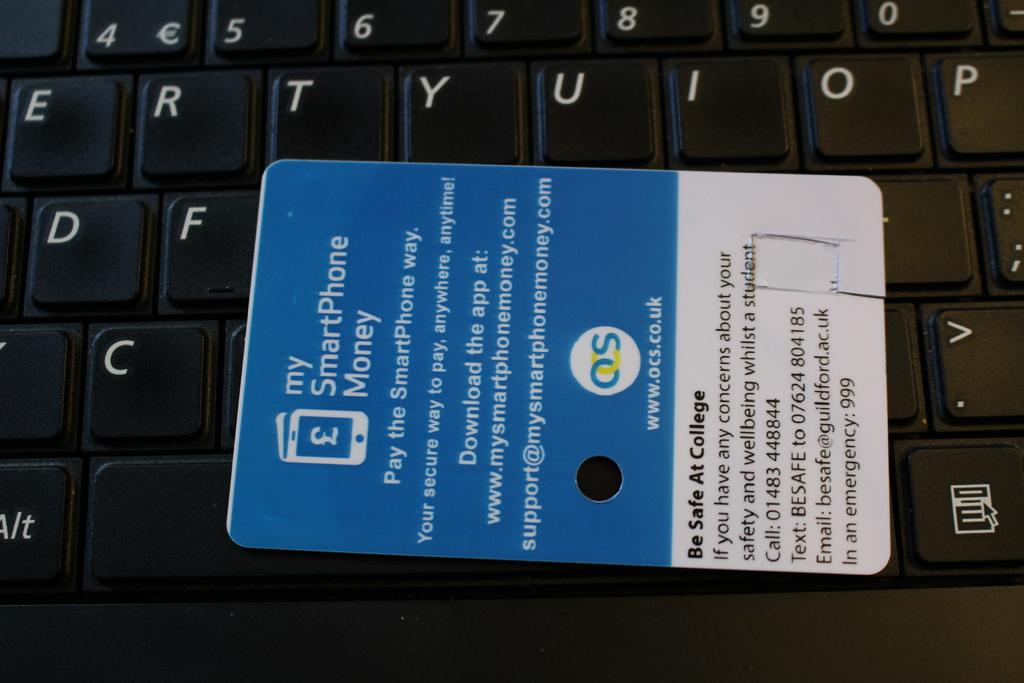<image>
Give a short and clear explanation of the subsequent image. A black keyboard with a plastic card that says my SmartPhone Money laying on top of the keyboard. 